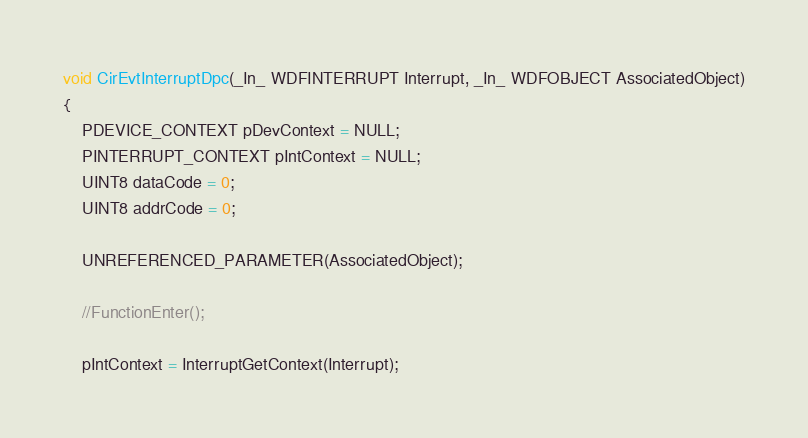<code> <loc_0><loc_0><loc_500><loc_500><_C++_>
void CirEvtInterruptDpc(_In_ WDFINTERRUPT Interrupt, _In_ WDFOBJECT AssociatedObject)
{
	PDEVICE_CONTEXT pDevContext = NULL;
	PINTERRUPT_CONTEXT pIntContext = NULL;
	UINT8 dataCode = 0;
	UINT8 addrCode = 0;

	UNREFERENCED_PARAMETER(AssociatedObject);

	//FunctionEnter();

	pIntContext = InterruptGetContext(Interrupt);</code> 